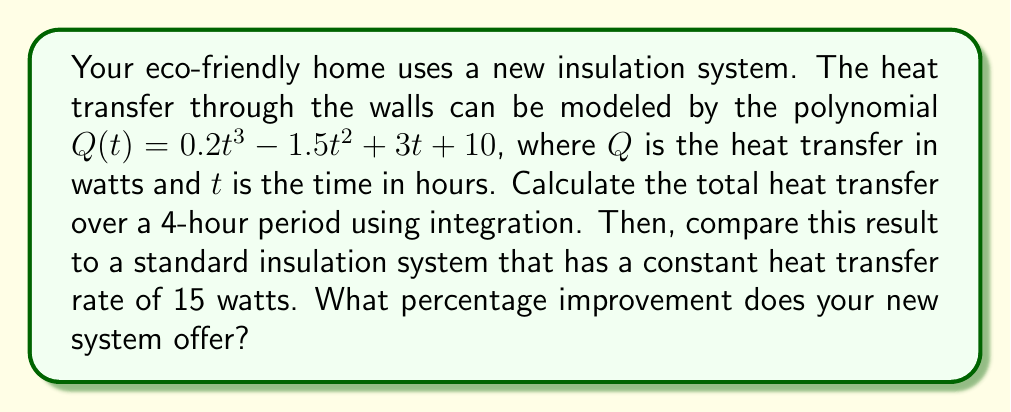Show me your answer to this math problem. To solve this problem, we'll follow these steps:

1) First, we need to integrate the heat transfer polynomial over the 4-hour period:

   $$\int_0^4 Q(t) dt = \int_0^4 (0.2t^3 - 1.5t^2 + 3t + 10) dt$$

2) Integrate each term:

   $$\left[\frac{0.2t^4}{4} - \frac{1.5t^3}{3} + \frac{3t^2}{2} + 10t\right]_0^4$$

3) Evaluate the integral:

   $$\left(\frac{0.2(4^4)}{4} - \frac{1.5(4^3)}{3} + \frac{3(4^2)}{2} + 10(4)\right) - \left(0 - 0 + 0 + 0\right)$$
   
   $$= (12.8 - 32 + 24 + 40) - 0 = 44.8 \text{ watt-hours}$$

4) For the standard insulation system with a constant rate of 15 watts:

   Total heat transfer = 15 watts × 4 hours = 60 watt-hours

5) Calculate the percentage improvement:

   Improvement = $\frac{60 - 44.8}{60} \times 100\% = 25.33\%$

Therefore, your new insulation system offers a 25.33% improvement in efficiency compared to the standard system.
Answer: The new insulation system offers a 25.33% improvement in efficiency. 